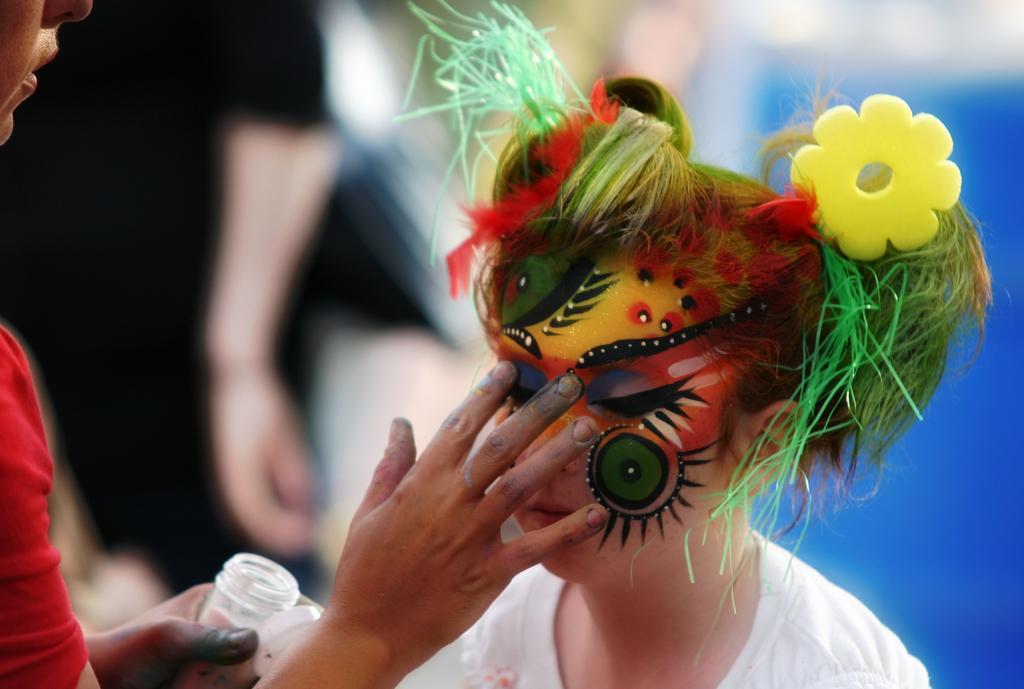Describe this image in one or two sentences. Background portion of the picture is blurry and we can see a person. In this picture we can see a person holding a bottle and painting the face of another person. We can see some objects and hair is dressed colorfully. 